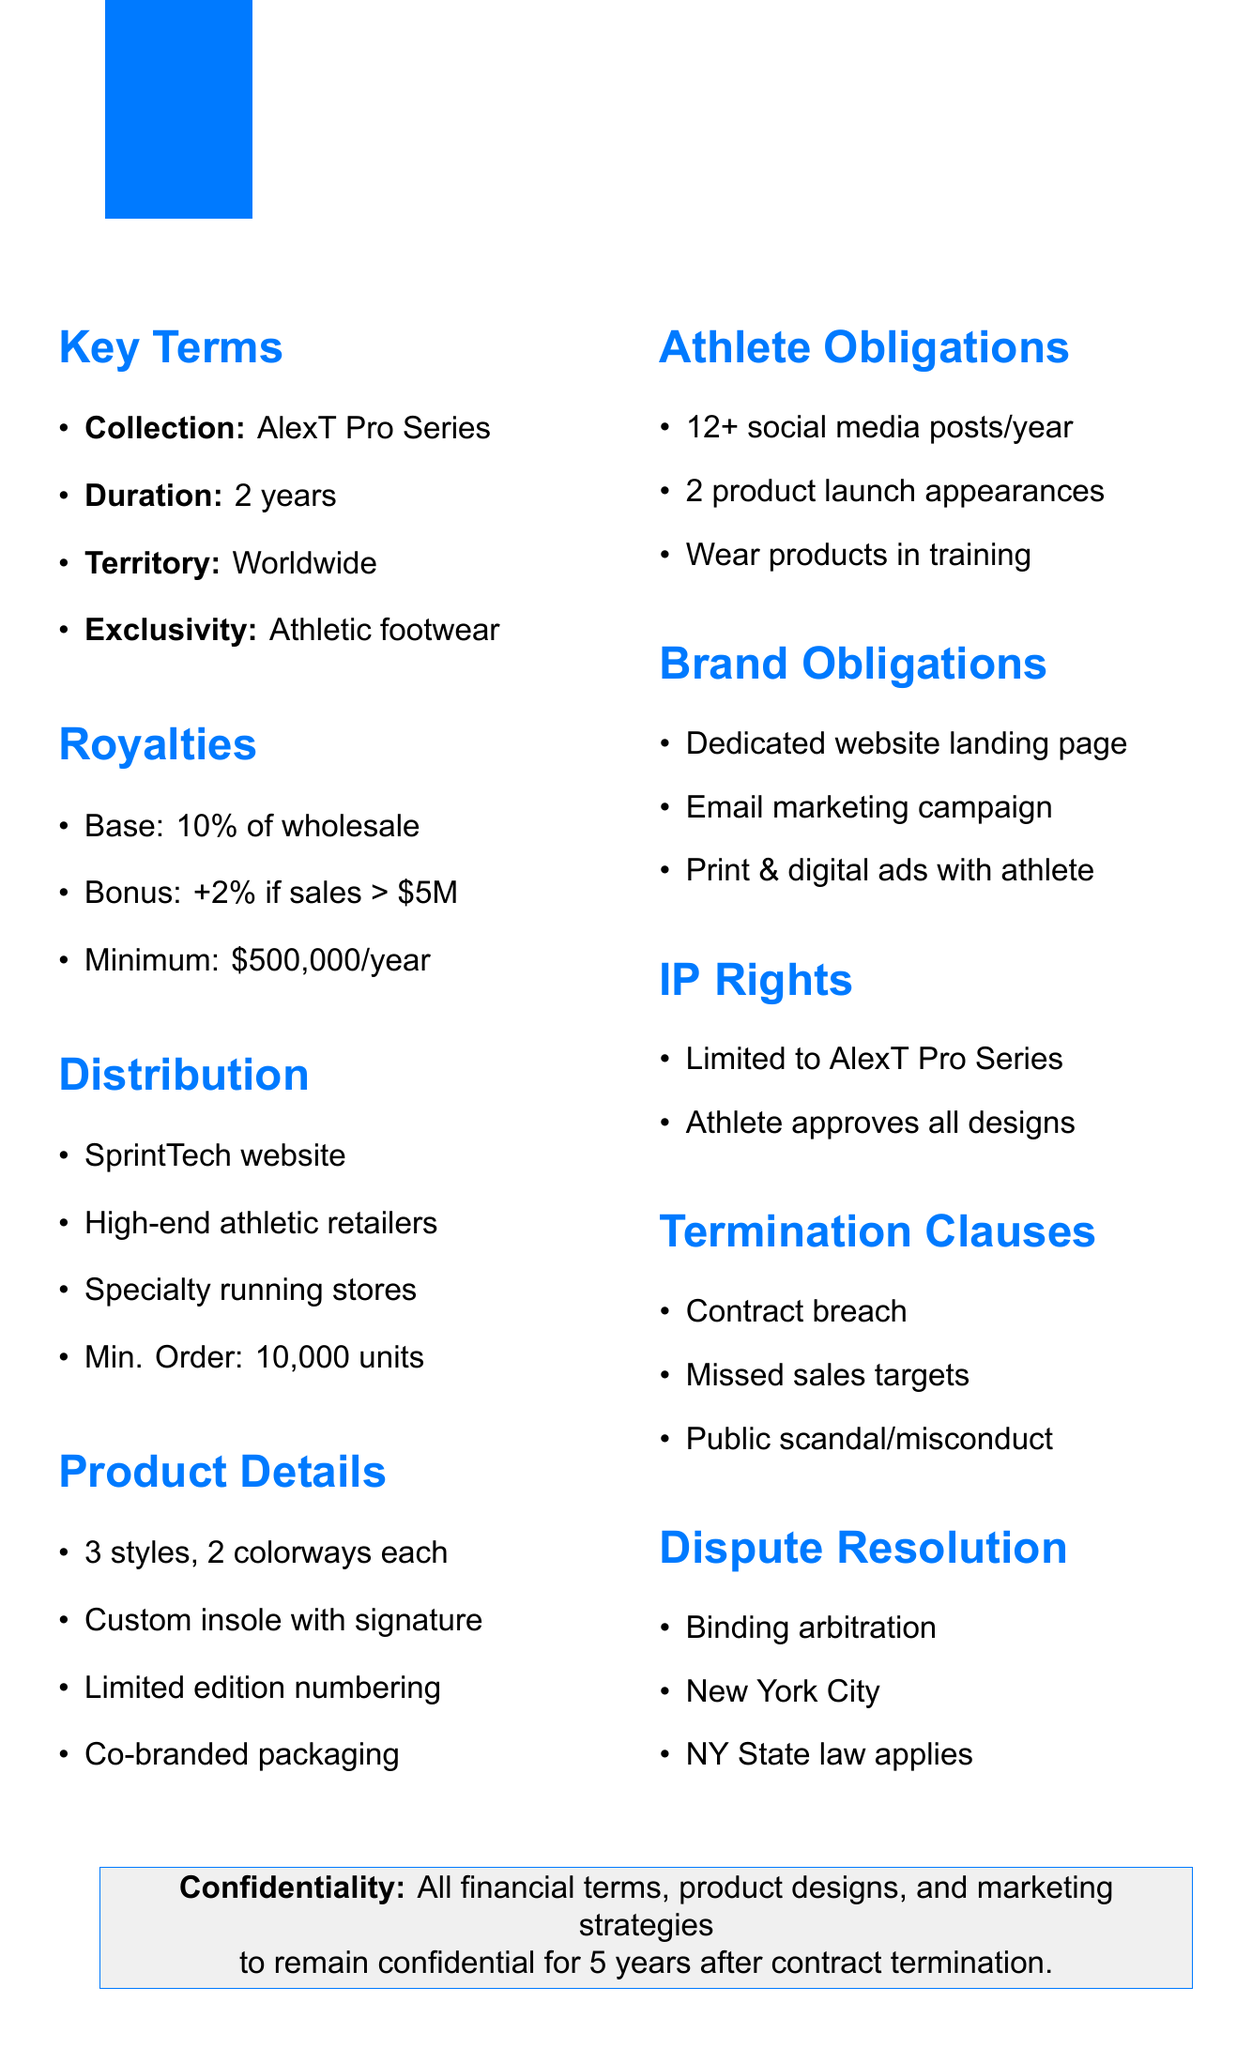What is the athlete's name? The document specifies the name of the athlete as Alex Thompson.
Answer: Alex Thompson What is the duration of the licensing agreement? The duration of the licensing agreement is mentioned in the key terms section.
Answer: 2 years What is the minimum guaranteed royalty per year? The royalty structure outlines the minimum guaranteed royalty.
Answer: $500,000 per year What is the base royalty percentage? The document lists the base royalty rate in the royalty section.
Answer: 10% of wholesale price How many styles are included in the collection? The product specifications section indicates the number of styles in the collection.
Answer: 3 What is the territory for the licensing agreement? The territory is specified in the key terms section of the document.
Answer: Worldwide How many social media posts must the athlete make per year? The marketing obligations section states the minimum requirement for social media posts.
Answer: Minimum 12 social media posts per year What happens if there is a breach of contract? A breach of contract is listed as one of the termination clauses in the document.
Answer: Termination What is the governing law for dispute resolution? The dispute resolution section specifies the governing law mentioned.
Answer: State of New York 